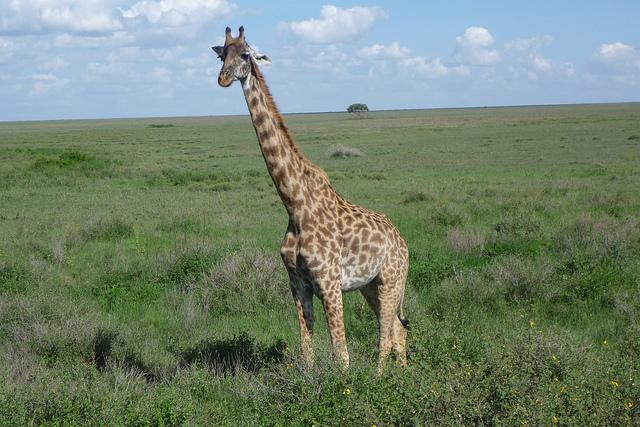Is this animal in captivity?
Keep it brief. No. Is the giraffe eating the bushes?
Short answer required. No. Are there clouds in the sky?
Quick response, please. Yes. What kind of animal is in the grass?
Answer briefly. Giraffe. 